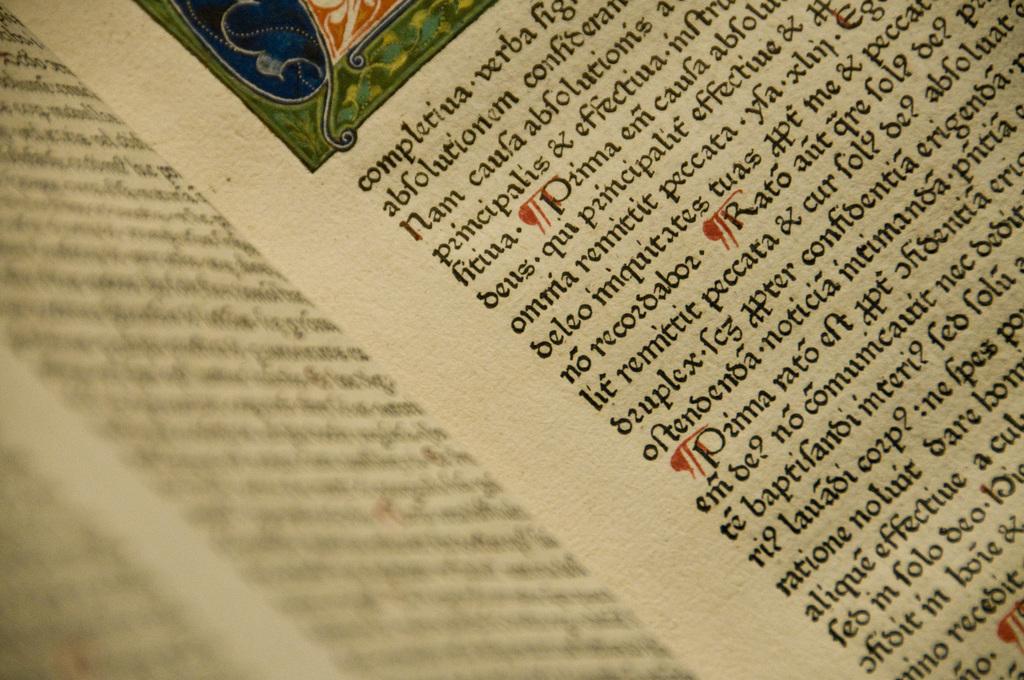What is the first latin word on the facing page?
Provide a succinct answer. Completiua. 